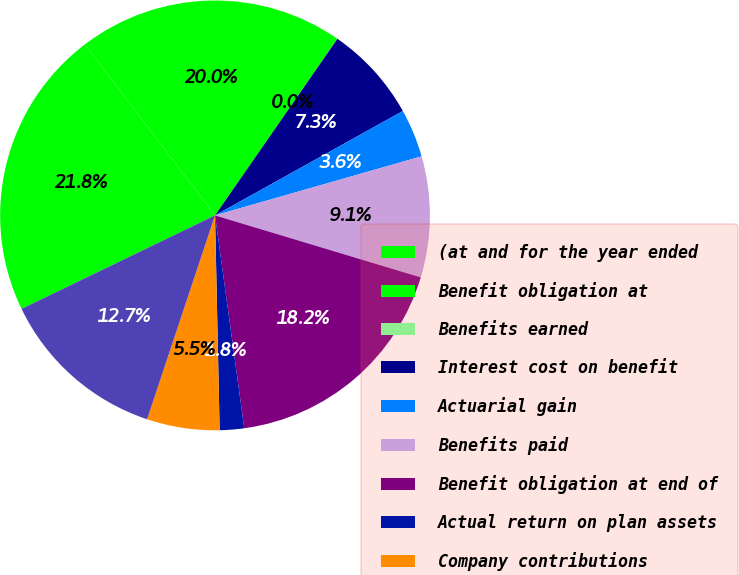<chart> <loc_0><loc_0><loc_500><loc_500><pie_chart><fcel>(at and for the year ended<fcel>Benefit obligation at<fcel>Benefits earned<fcel>Interest cost on benefit<fcel>Actuarial gain<fcel>Benefits paid<fcel>Benefit obligation at end of<fcel>Actual return on plan assets<fcel>Company contributions<fcel>Fair value of plan assets at<nl><fcel>21.81%<fcel>19.99%<fcel>0.01%<fcel>7.28%<fcel>3.64%<fcel>9.09%<fcel>18.17%<fcel>1.83%<fcel>5.46%<fcel>12.72%<nl></chart> 